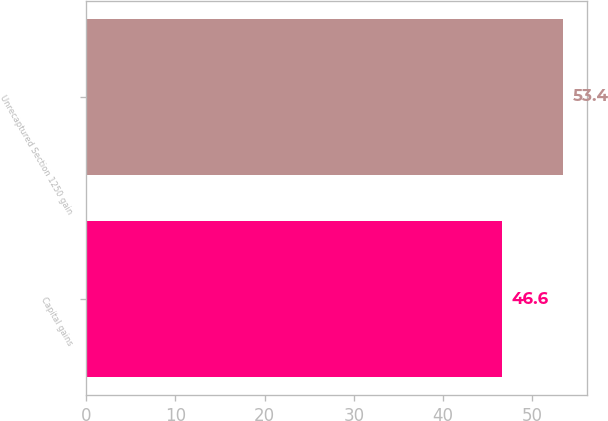<chart> <loc_0><loc_0><loc_500><loc_500><bar_chart><fcel>Capital gains<fcel>Unrecaptured Section 1250 gain<nl><fcel>46.6<fcel>53.4<nl></chart> 